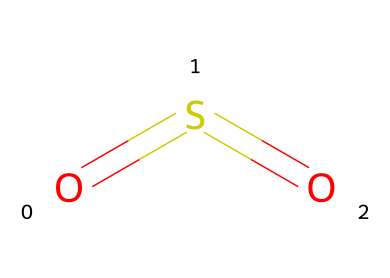What is the chemical name of the compound represented? The SMILES representation O=S=O indicates that the compound consists of one sulfur atom bonded to two oxygen atoms through double bonds, which is known as sulfur dioxide.
Answer: sulfur dioxide How many atoms are present in the molecular structure? By examining the SMILES notation, we count 1 sulfur atom and 2 oxygen atoms, totaling 3 atoms in the molecular structure.
Answer: three How many double bonds are present in sulfur dioxide? The SMILES notation O=S=O shows two equal signs which represent double bonds between the sulfur and each of the oxygen atoms. Thus, there are 2 double bonds in total.
Answer: two Is sulfur dioxide considered an organosulfur compound? Organosulfur compounds are characterized by the presence of sulfur atoms attached to carbon-containing moieties. Since sulfur dioxide does not contain carbon, it does not classify as an organosulfur compound.
Answer: no What role does sulfur dioxide play in environmental issues? Sulfur dioxide is a significant air pollutant that contributes to the formation of acid rain. Its presence in the atmosphere leads to environmental degradation and various health implications.
Answer: acid rain What state of matter is sulfur dioxide at room temperature? Sulfur dioxide is typically a gas at room temperature and pressure. This is also evident from its low boiling point of -10 degrees Celsius.
Answer: gas 